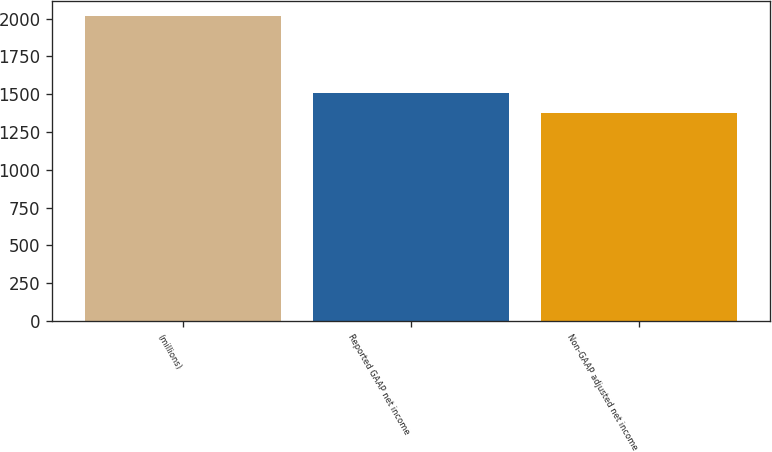Convert chart to OTSL. <chart><loc_0><loc_0><loc_500><loc_500><bar_chart><fcel>(millions)<fcel>Reported GAAP net income<fcel>Non-GAAP adjusted net income<nl><fcel>2017<fcel>1508.4<fcel>1378.2<nl></chart> 